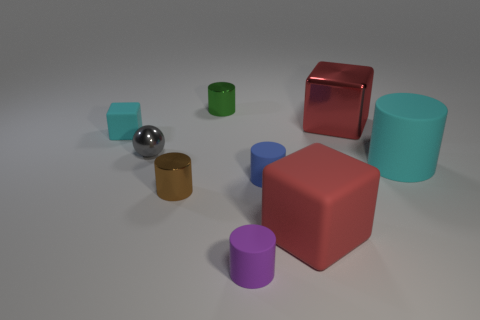What is the shape of the tiny blue thing? The small blue object in the image appears to be a cylinder with a circular base, standing upright on one of its flat circular faces. 